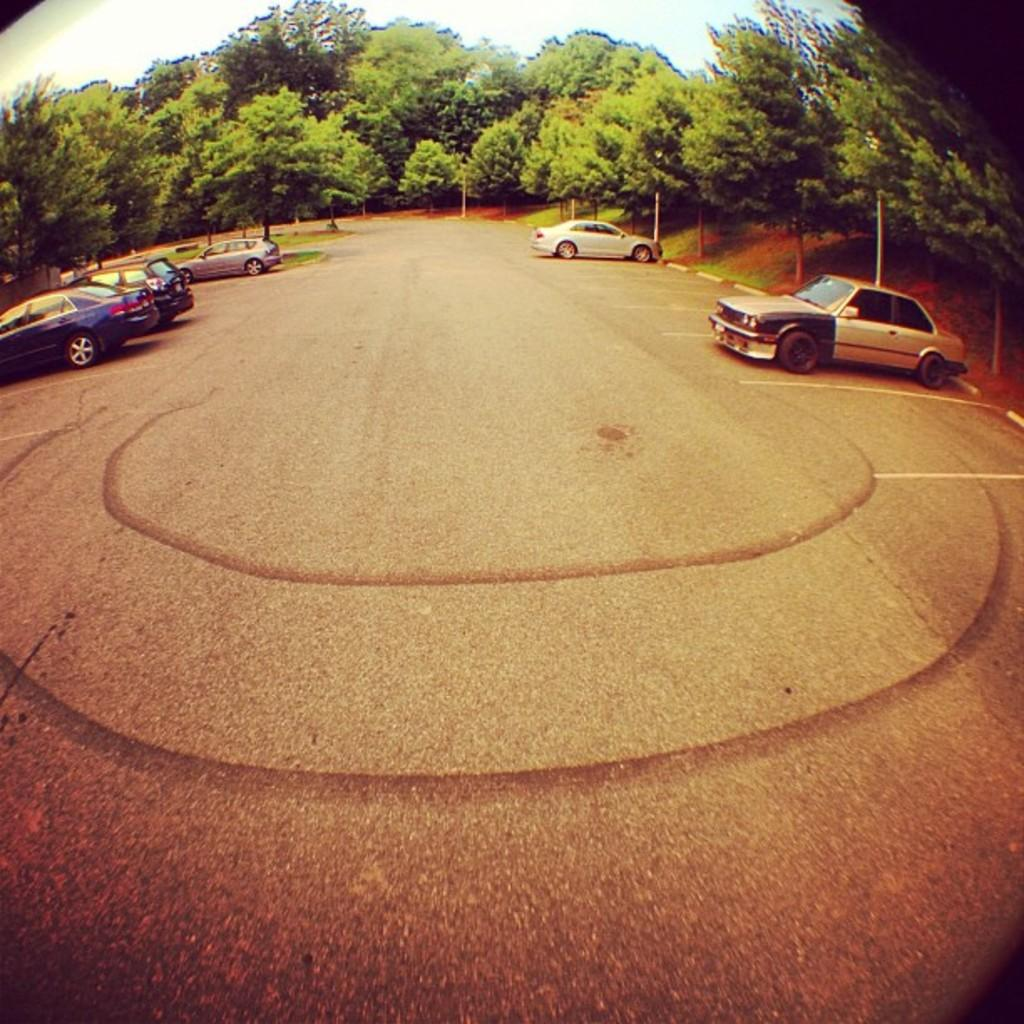What can be seen on the road in the image? There are cars parked on the road in the image. What part of the image shows the road? The road is visible at the bottom of the image. What type of vegetation is in the background of the image? There are trees in the background of the image. What is visible at the top of the image? The sky is visible at the top of the image. What type of rod is being used by the servant in the image? There is no servant or rod present in the image. Can you tell me how many baseballs are visible in the image? There are no baseballs present in the image. 